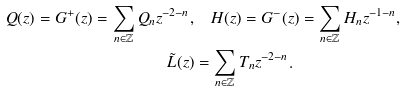Convert formula to latex. <formula><loc_0><loc_0><loc_500><loc_500>Q ( z ) = G ^ { + } ( z ) = \sum _ { n \in \mathbb { Z } } Q _ { n } z ^ { - 2 - n } , & \quad H ( z ) = G ^ { - } ( z ) = \sum _ { n \in \mathbb { Z } } H _ { n } z ^ { - 1 - n } , \\ \tilde { L } ( z ) & = \sum _ { n \in \mathbb { Z } } T _ { n } z ^ { - 2 - n } . \\</formula> 